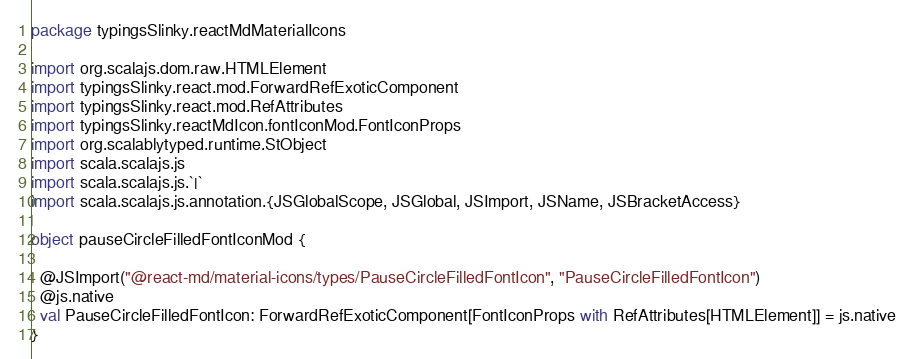<code> <loc_0><loc_0><loc_500><loc_500><_Scala_>package typingsSlinky.reactMdMaterialIcons

import org.scalajs.dom.raw.HTMLElement
import typingsSlinky.react.mod.ForwardRefExoticComponent
import typingsSlinky.react.mod.RefAttributes
import typingsSlinky.reactMdIcon.fontIconMod.FontIconProps
import org.scalablytyped.runtime.StObject
import scala.scalajs.js
import scala.scalajs.js.`|`
import scala.scalajs.js.annotation.{JSGlobalScope, JSGlobal, JSImport, JSName, JSBracketAccess}

object pauseCircleFilledFontIconMod {
  
  @JSImport("@react-md/material-icons/types/PauseCircleFilledFontIcon", "PauseCircleFilledFontIcon")
  @js.native
  val PauseCircleFilledFontIcon: ForwardRefExoticComponent[FontIconProps with RefAttributes[HTMLElement]] = js.native
}
</code> 